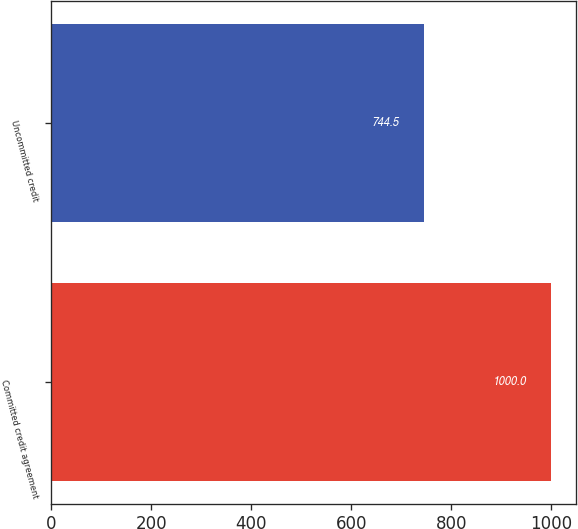Convert chart to OTSL. <chart><loc_0><loc_0><loc_500><loc_500><bar_chart><fcel>Committed credit agreement<fcel>Uncommitted credit<nl><fcel>1000<fcel>744.5<nl></chart> 